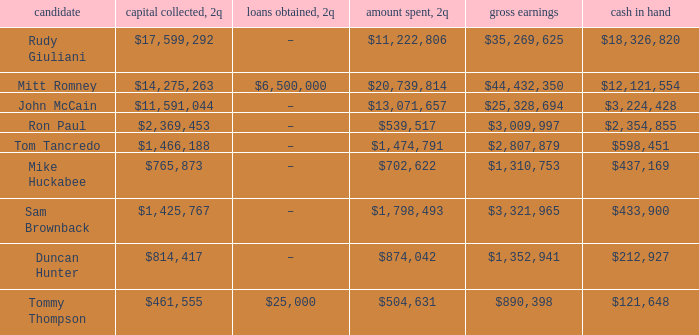Name the loans received for 2Q having total receipts of $25,328,694 –. 